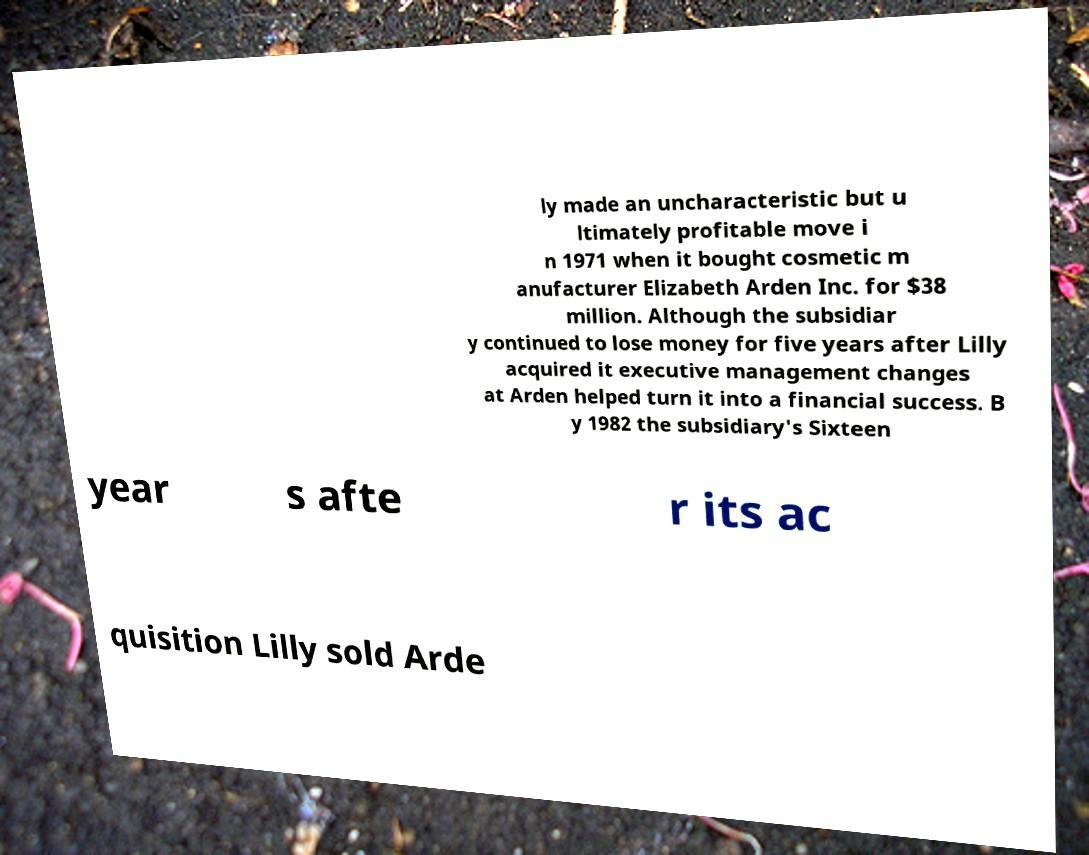Please identify and transcribe the text found in this image. ly made an uncharacteristic but u ltimately profitable move i n 1971 when it bought cosmetic m anufacturer Elizabeth Arden Inc. for $38 million. Although the subsidiar y continued to lose money for five years after Lilly acquired it executive management changes at Arden helped turn it into a financial success. B y 1982 the subsidiary's Sixteen year s afte r its ac quisition Lilly sold Arde 